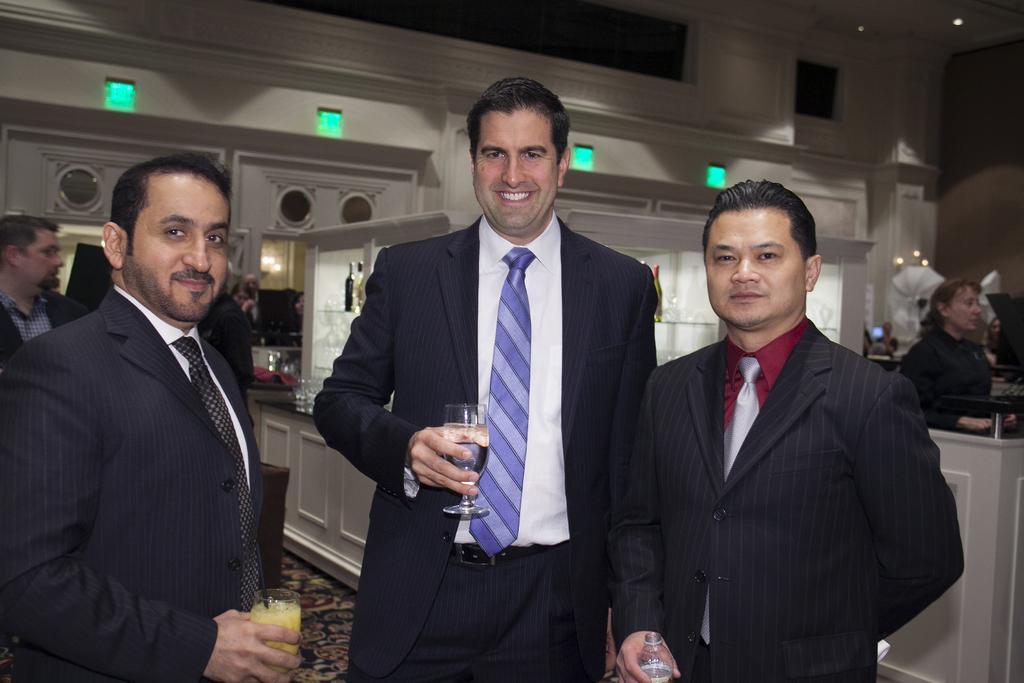How would you summarize this image in a sentence or two? In this image three people standing in the center of the image are holding glasses in their hands and posing for the picture. I can see other people behind them. I can see some wooden shelves with glasses and bottles on them. I can see a wall with lights behind. The background is blurred. 